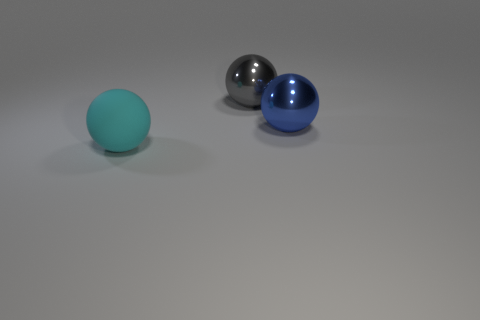Subtract 1 spheres. How many spheres are left? 2 Subtract all cyan rubber balls. How many balls are left? 2 Add 2 big blue things. How many objects exist? 5 Subtract all brown rubber things. Subtract all cyan rubber balls. How many objects are left? 2 Add 2 cyan objects. How many cyan objects are left? 3 Add 3 cyan things. How many cyan things exist? 4 Subtract 0 brown cylinders. How many objects are left? 3 